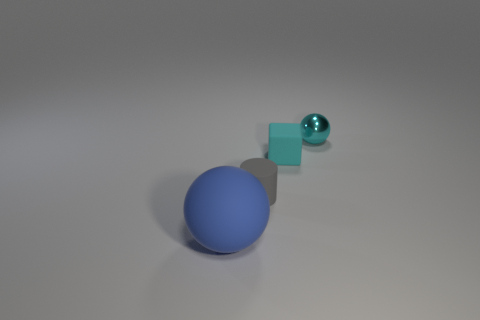Do the large matte thing and the small ball have the same color?
Your answer should be compact. No. Is the number of large matte spheres to the left of the tiny cyan rubber cube less than the number of things?
Provide a short and direct response. Yes. What is the color of the small object that is to the right of the cyan matte cube?
Offer a terse response. Cyan. There is a gray matte thing; what shape is it?
Ensure brevity in your answer.  Cylinder. Are there any blocks on the right side of the sphere that is behind the object in front of the small cylinder?
Give a very brief answer. No. What is the color of the ball that is in front of the sphere that is behind the sphere in front of the small shiny ball?
Keep it short and to the point. Blue. There is another thing that is the same shape as the blue thing; what is its material?
Make the answer very short. Metal. There is a cyan object that is to the left of the ball to the right of the matte ball; what size is it?
Give a very brief answer. Small. What material is the blue thing left of the tiny matte cylinder?
Ensure brevity in your answer.  Rubber. There is a blue object that is the same material as the tiny cyan cube; what is its size?
Keep it short and to the point. Large. 